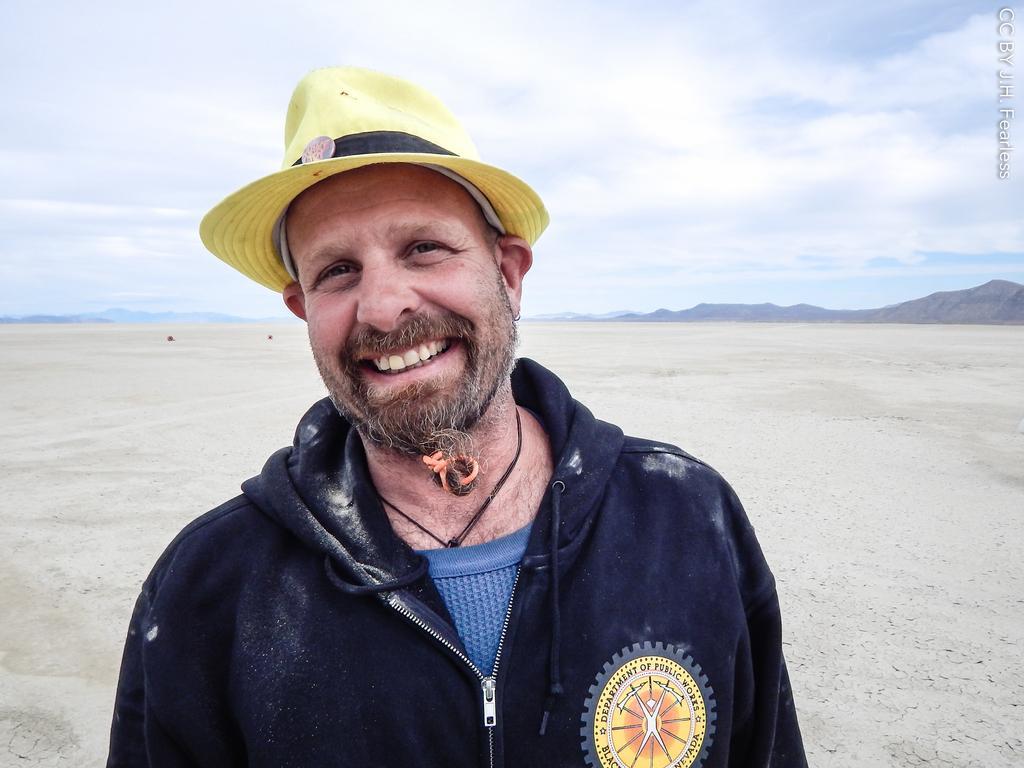How would you summarize this image in a sentence or two? In this picture I can see a man smiling, there are hills, and in the background there is the sky. 